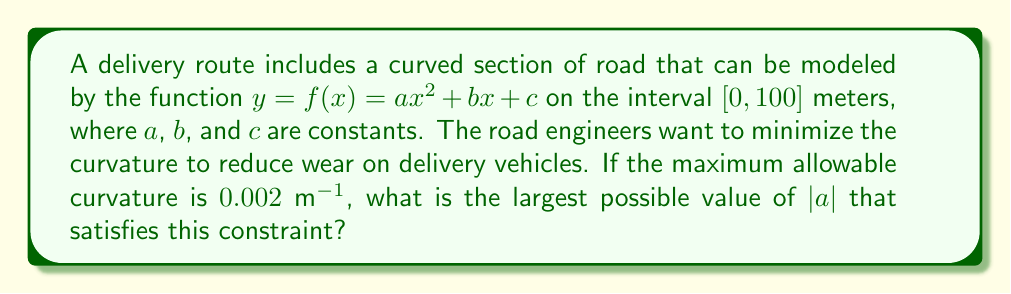Can you answer this question? To solve this problem, we need to follow these steps:

1) The curvature $\kappa$ of a curve $y = f(x)$ is given by the formula:

   $$\kappa = \frac{|f''(x)|}{(1 + [f'(x)]^2)^{3/2}}$$

2) For the given function $f(x) = ax^2 + bx + c$, we have:
   
   $f'(x) = 2ax + b$
   $f''(x) = 2a$

3) Substituting these into the curvature formula:

   $$\kappa = \frac{|2a|}{(1 + [2ax + b]^2)^{3/2}}$$

4) The maximum curvature will occur where the denominator is at its minimum. The minimum value of $(1 + [2ax + b]^2)^{3/2}$ is 1, which occurs when $2ax + b = 0$.

5) Therefore, the maximum curvature is:

   $$\kappa_{max} = |2a|$$

6) We're given that the maximum allowable curvature is 0.002 m$^{-1}$. So:

   $$|2a| \leq 0.002$$

7) Solving for $|a|$:

   $$|a| \leq 0.001$$

Therefore, the largest possible value of $|a|$ that satisfies the curvature constraint is 0.001.
Answer: The largest possible value of $|a|$ is 0.001 m$^{-1}$. 